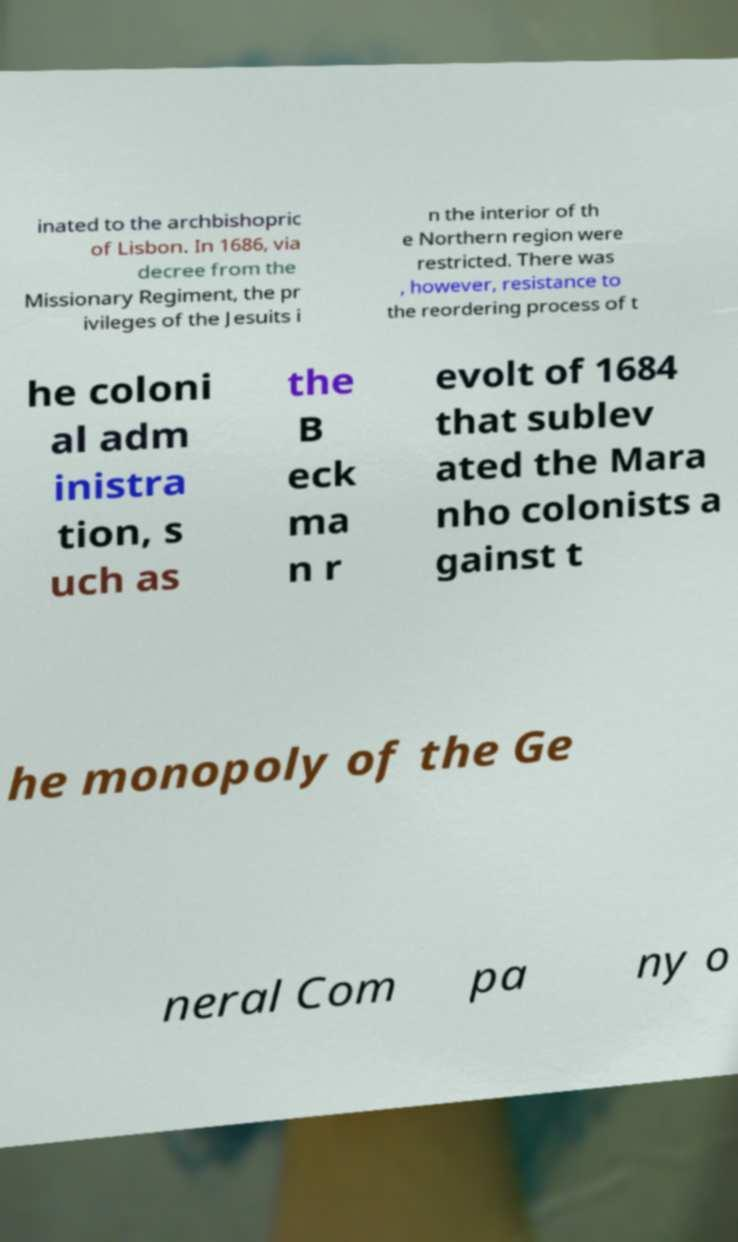What messages or text are displayed in this image? I need them in a readable, typed format. inated to the archbishopric of Lisbon. In 1686, via decree from the Missionary Regiment, the pr ivileges of the Jesuits i n the interior of th e Northern region were restricted. There was , however, resistance to the reordering process of t he coloni al adm inistra tion, s uch as the B eck ma n r evolt of 1684 that sublev ated the Mara nho colonists a gainst t he monopoly of the Ge neral Com pa ny o 